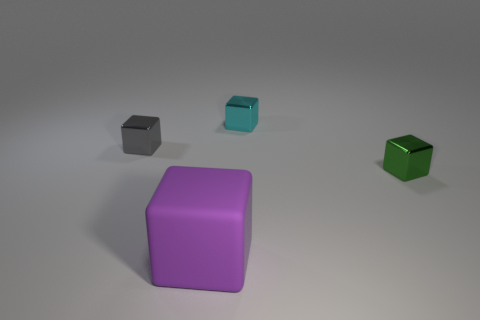Add 4 yellow matte cylinders. How many objects exist? 8 Subtract all small green cubes. How many cubes are left? 3 Subtract 1 blocks. How many blocks are left? 3 Subtract all green blocks. How many blocks are left? 3 Add 3 large red shiny objects. How many large red shiny objects exist? 3 Subtract 0 gray balls. How many objects are left? 4 Subtract all red blocks. Subtract all red cylinders. How many blocks are left? 4 Subtract all big yellow metallic objects. Subtract all cyan blocks. How many objects are left? 3 Add 3 green metallic objects. How many green metallic objects are left? 4 